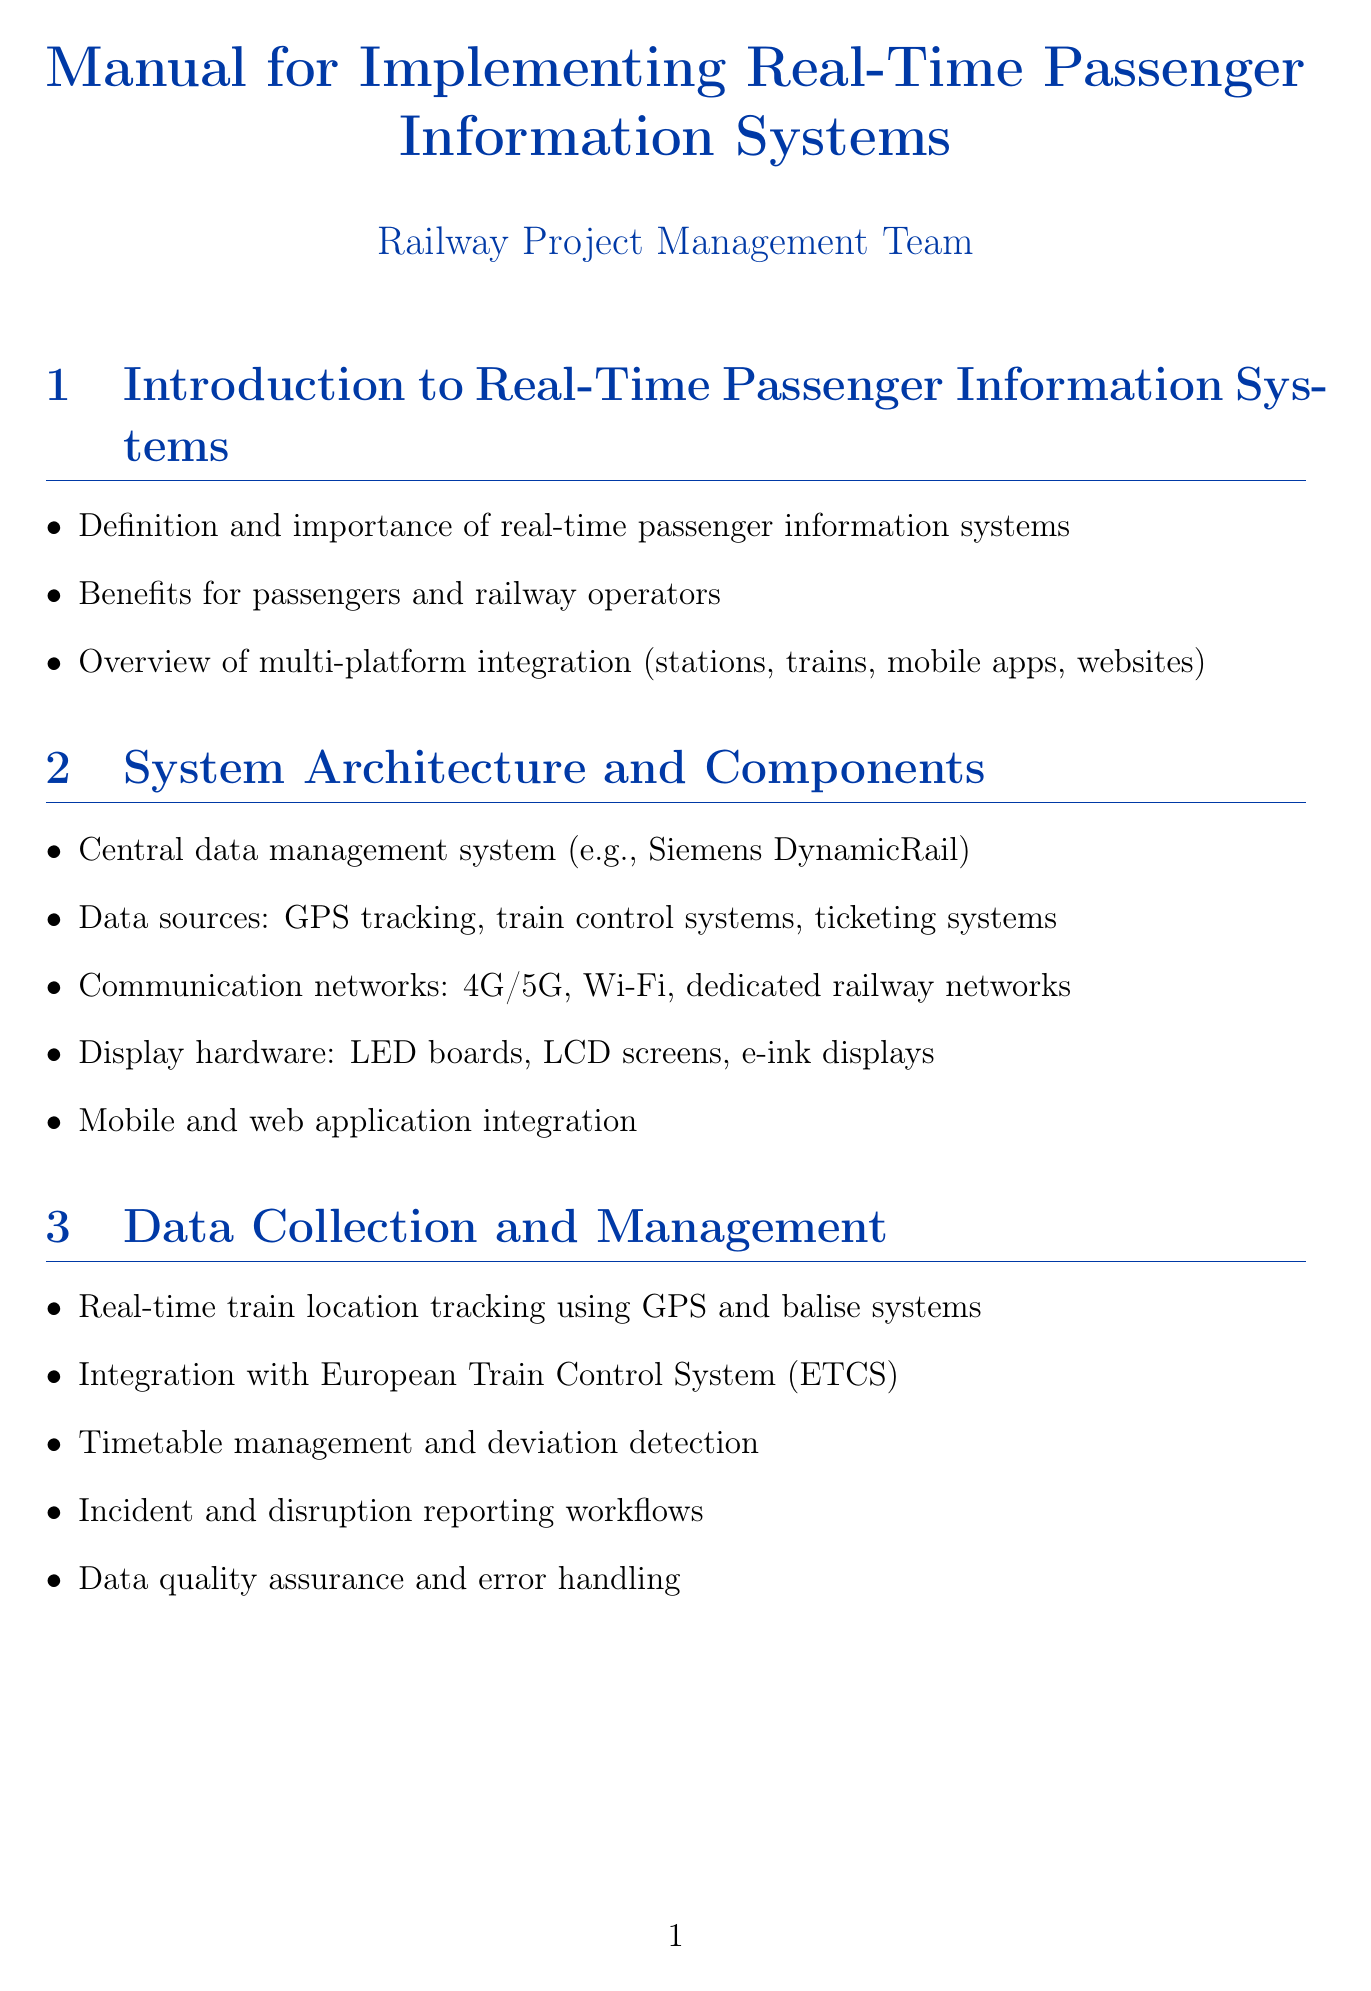What is the title of the manual? The title of the manual is found in the document's cover section.
Answer: Manual for Implementing Real-Time Passenger Information Systems What is one key benefit of real-time passenger information systems? Benefits for passengers and railway operators are listed in the introduction section of the document.
Answer: Improved communication What communication networks are mentioned? The section on system architecture outlines various communication networks available for integration.
Answer: 4G/5G, Wi-Fi, dedicated railway networks What is a feature of mobile apps mentioned in the document? Platform-specific implementation discusses mobile app features to enhance passenger experience.
Answer: Push notifications How should content be prioritized for different platforms? Information display guidelines provide recommendations on how to handle content for various platforms.
Answer: Content prioritization for different platforms What does the implementation of feedback mechanisms aim for? Passenger-centric features explore enhancing the travel experience through user feedback processes.
Answer: Continuous improvement What regulatory compliance is mentioned in the manual? The compliance and standards section details legal requirements relevant to rail passenger rights.
Answer: EU Regulation 1371/2007 What type of testing is included in the quality assurance section? The system testing and quality assurance section describes various testing methods for effective assessment.
Answer: User acceptance testing Where can one find case studies within the document? The case studies and best practices section presents examples of successful implementations of information systems.
Answer: Case Studies and Best Practices 